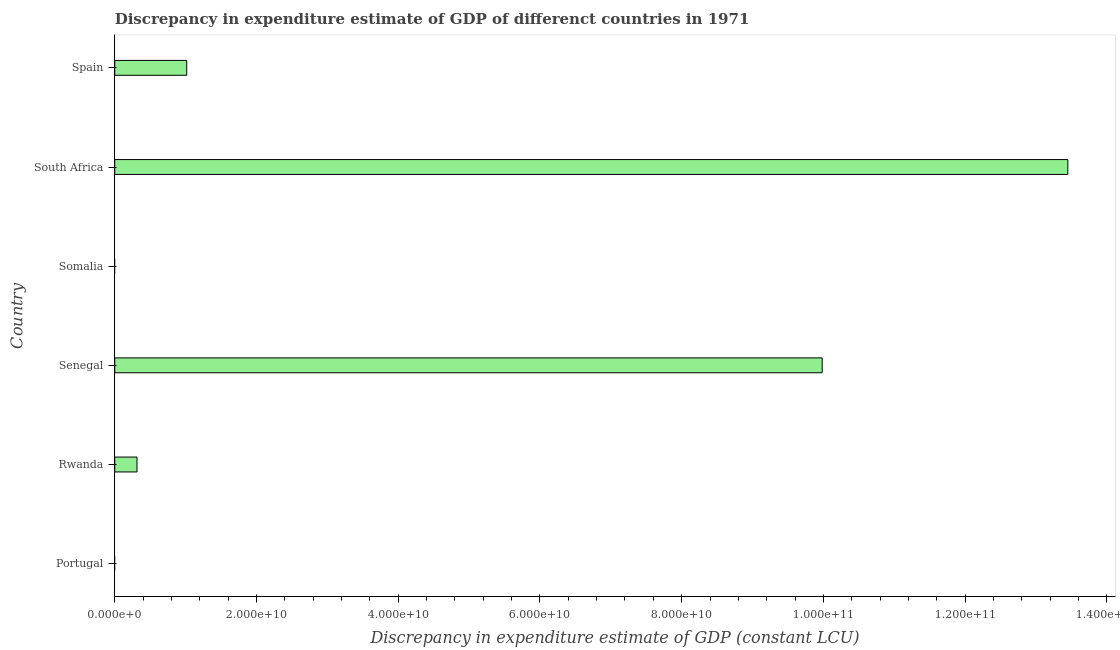Does the graph contain grids?
Make the answer very short. No. What is the title of the graph?
Offer a very short reply. Discrepancy in expenditure estimate of GDP of differenct countries in 1971. What is the label or title of the X-axis?
Your answer should be very brief. Discrepancy in expenditure estimate of GDP (constant LCU). What is the label or title of the Y-axis?
Your answer should be compact. Country. Across all countries, what is the maximum discrepancy in expenditure estimate of gdp?
Keep it short and to the point. 1.34e+11. In which country was the discrepancy in expenditure estimate of gdp maximum?
Make the answer very short. South Africa. What is the sum of the discrepancy in expenditure estimate of gdp?
Provide a short and direct response. 2.48e+11. What is the difference between the discrepancy in expenditure estimate of gdp in Senegal and Spain?
Keep it short and to the point. 8.97e+1. What is the average discrepancy in expenditure estimate of gdp per country?
Give a very brief answer. 4.13e+1. What is the median discrepancy in expenditure estimate of gdp?
Offer a terse response. 6.65e+09. What is the ratio of the discrepancy in expenditure estimate of gdp in Rwanda to that in Spain?
Your response must be concise. 0.31. Is the discrepancy in expenditure estimate of gdp in Rwanda less than that in Spain?
Your answer should be compact. Yes. What is the difference between the highest and the second highest discrepancy in expenditure estimate of gdp?
Keep it short and to the point. 3.47e+1. What is the difference between the highest and the lowest discrepancy in expenditure estimate of gdp?
Your response must be concise. 1.34e+11. Are all the bars in the graph horizontal?
Keep it short and to the point. Yes. What is the Discrepancy in expenditure estimate of GDP (constant LCU) in Rwanda?
Give a very brief answer. 3.14e+09. What is the Discrepancy in expenditure estimate of GDP (constant LCU) of Senegal?
Offer a terse response. 9.98e+1. What is the Discrepancy in expenditure estimate of GDP (constant LCU) of Somalia?
Ensure brevity in your answer.  0. What is the Discrepancy in expenditure estimate of GDP (constant LCU) in South Africa?
Offer a terse response. 1.34e+11. What is the Discrepancy in expenditure estimate of GDP (constant LCU) of Spain?
Offer a very short reply. 1.02e+1. What is the difference between the Discrepancy in expenditure estimate of GDP (constant LCU) in Rwanda and Senegal?
Your answer should be compact. -9.67e+1. What is the difference between the Discrepancy in expenditure estimate of GDP (constant LCU) in Rwanda and South Africa?
Provide a short and direct response. -1.31e+11. What is the difference between the Discrepancy in expenditure estimate of GDP (constant LCU) in Rwanda and Spain?
Ensure brevity in your answer.  -7.02e+09. What is the difference between the Discrepancy in expenditure estimate of GDP (constant LCU) in Senegal and South Africa?
Provide a short and direct response. -3.47e+1. What is the difference between the Discrepancy in expenditure estimate of GDP (constant LCU) in Senegal and Spain?
Ensure brevity in your answer.  8.97e+1. What is the difference between the Discrepancy in expenditure estimate of GDP (constant LCU) in South Africa and Spain?
Give a very brief answer. 1.24e+11. What is the ratio of the Discrepancy in expenditure estimate of GDP (constant LCU) in Rwanda to that in Senegal?
Your response must be concise. 0.03. What is the ratio of the Discrepancy in expenditure estimate of GDP (constant LCU) in Rwanda to that in South Africa?
Give a very brief answer. 0.02. What is the ratio of the Discrepancy in expenditure estimate of GDP (constant LCU) in Rwanda to that in Spain?
Your answer should be very brief. 0.31. What is the ratio of the Discrepancy in expenditure estimate of GDP (constant LCU) in Senegal to that in South Africa?
Make the answer very short. 0.74. What is the ratio of the Discrepancy in expenditure estimate of GDP (constant LCU) in Senegal to that in Spain?
Ensure brevity in your answer.  9.83. What is the ratio of the Discrepancy in expenditure estimate of GDP (constant LCU) in South Africa to that in Spain?
Offer a terse response. 13.24. 